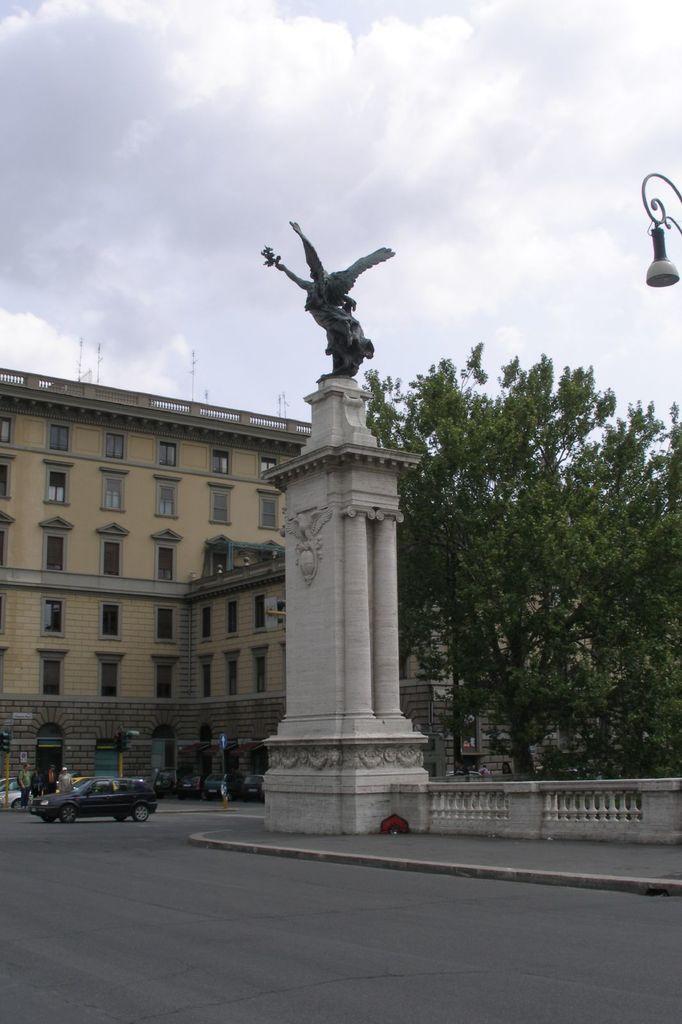Could you give a brief overview of what you see in this image? In this picture, we can see a sculpture on the stone placed side to the road and also a vehicle moving on the road. In the background, there are trees, building, street light, the sky and the clouds.. 